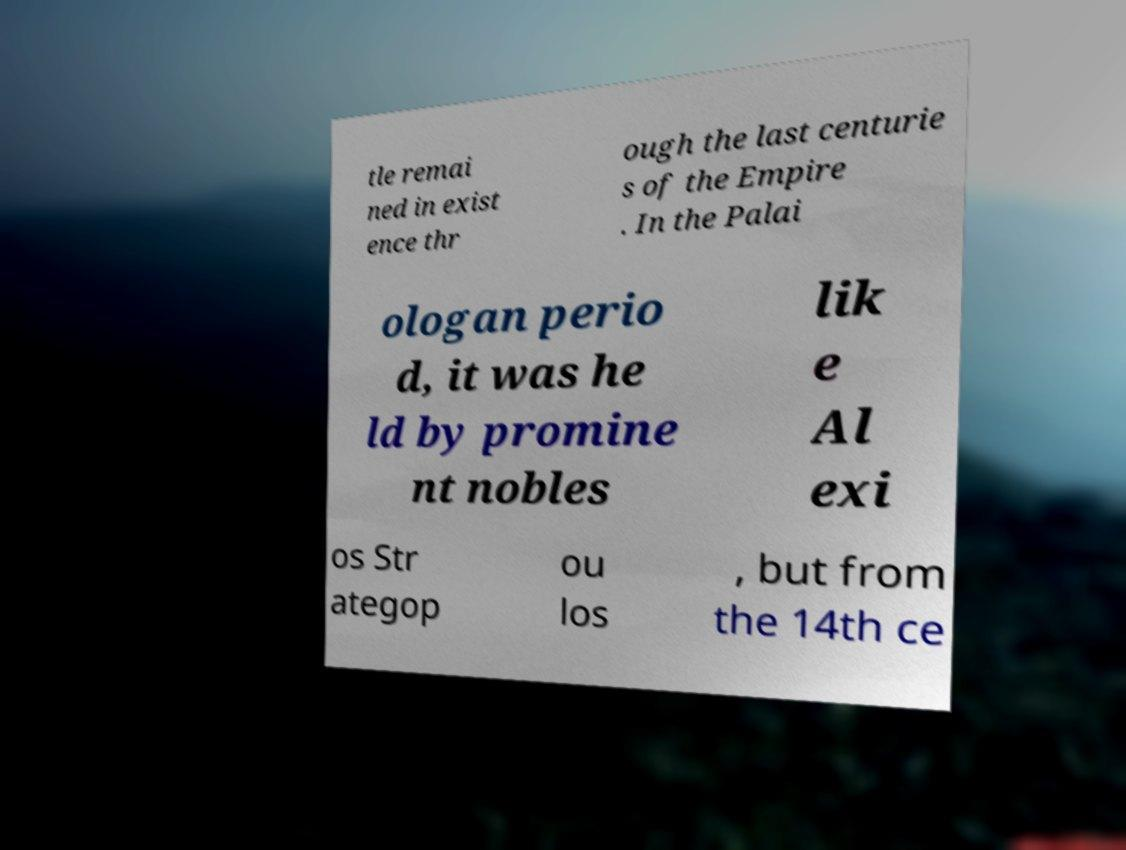Could you extract and type out the text from this image? tle remai ned in exist ence thr ough the last centurie s of the Empire . In the Palai ologan perio d, it was he ld by promine nt nobles lik e Al exi os Str ategop ou los , but from the 14th ce 